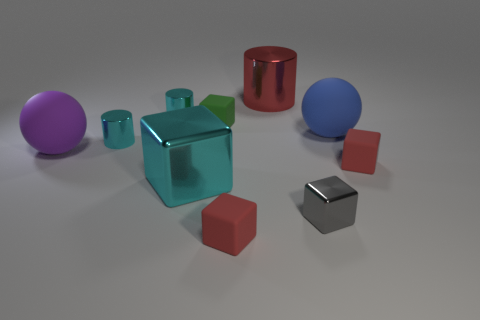Is there a tiny metal thing that has the same color as the large block?
Provide a succinct answer. Yes. There is a red matte object that is on the left side of the big red object; does it have the same shape as the tiny gray shiny object?
Keep it short and to the point. Yes. How many cyan metal cubes have the same size as the red metal cylinder?
Offer a terse response. 1. How many red matte cubes are to the right of the red thing that is behind the purple rubber ball?
Your answer should be compact. 1. Do the cyan cylinder behind the blue rubber sphere and the green block have the same material?
Provide a succinct answer. No. Are the large thing right of the large metal cylinder and the small cube that is behind the purple sphere made of the same material?
Provide a short and direct response. Yes. Are there more small gray shiny things that are right of the purple matte sphere than big purple cylinders?
Your answer should be compact. Yes. What is the color of the big shiny object that is behind the sphere that is left of the tiny green object?
Offer a terse response. Red. What shape is the green object that is the same size as the gray block?
Your response must be concise. Cube. Are there the same number of cyan shiny cubes that are left of the red cylinder and large purple rubber things?
Ensure brevity in your answer.  Yes. 